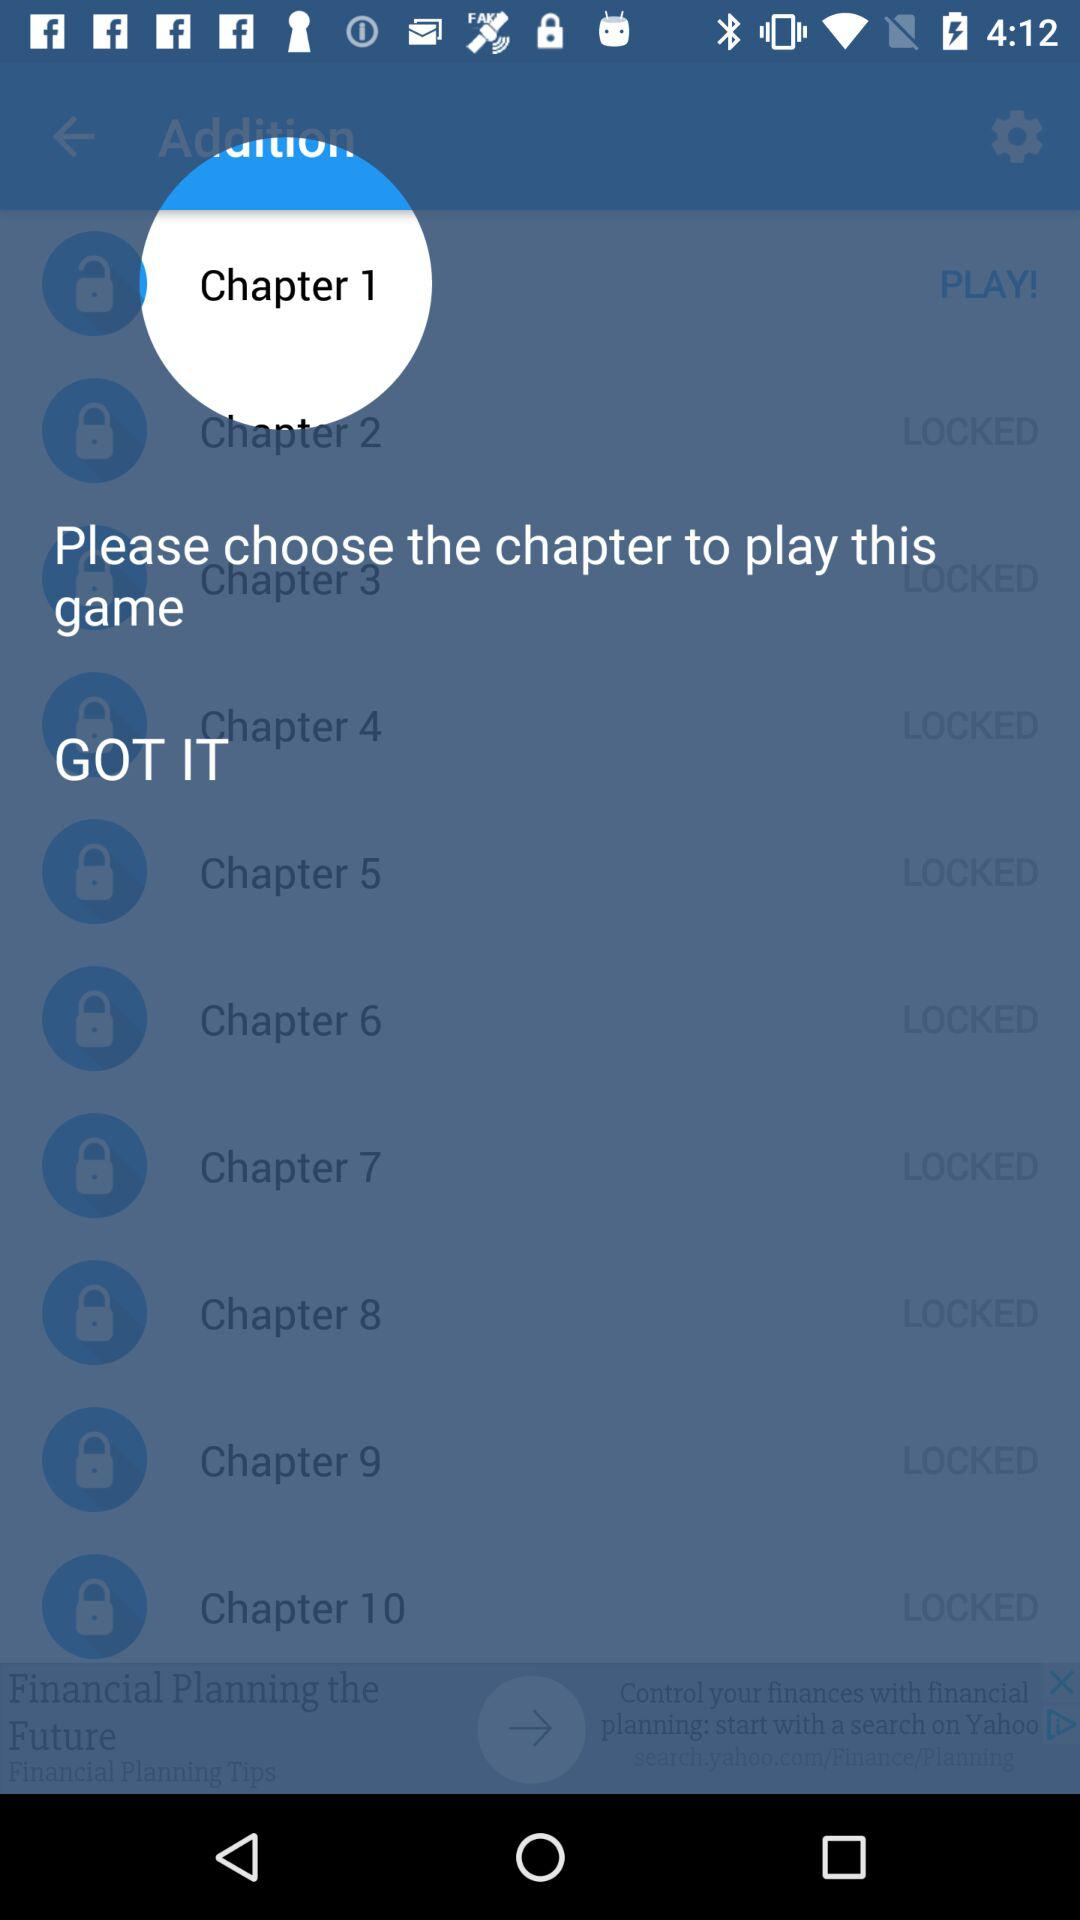How many chapters are available to play in the game?
Answer the question using a single word or phrase. 10 